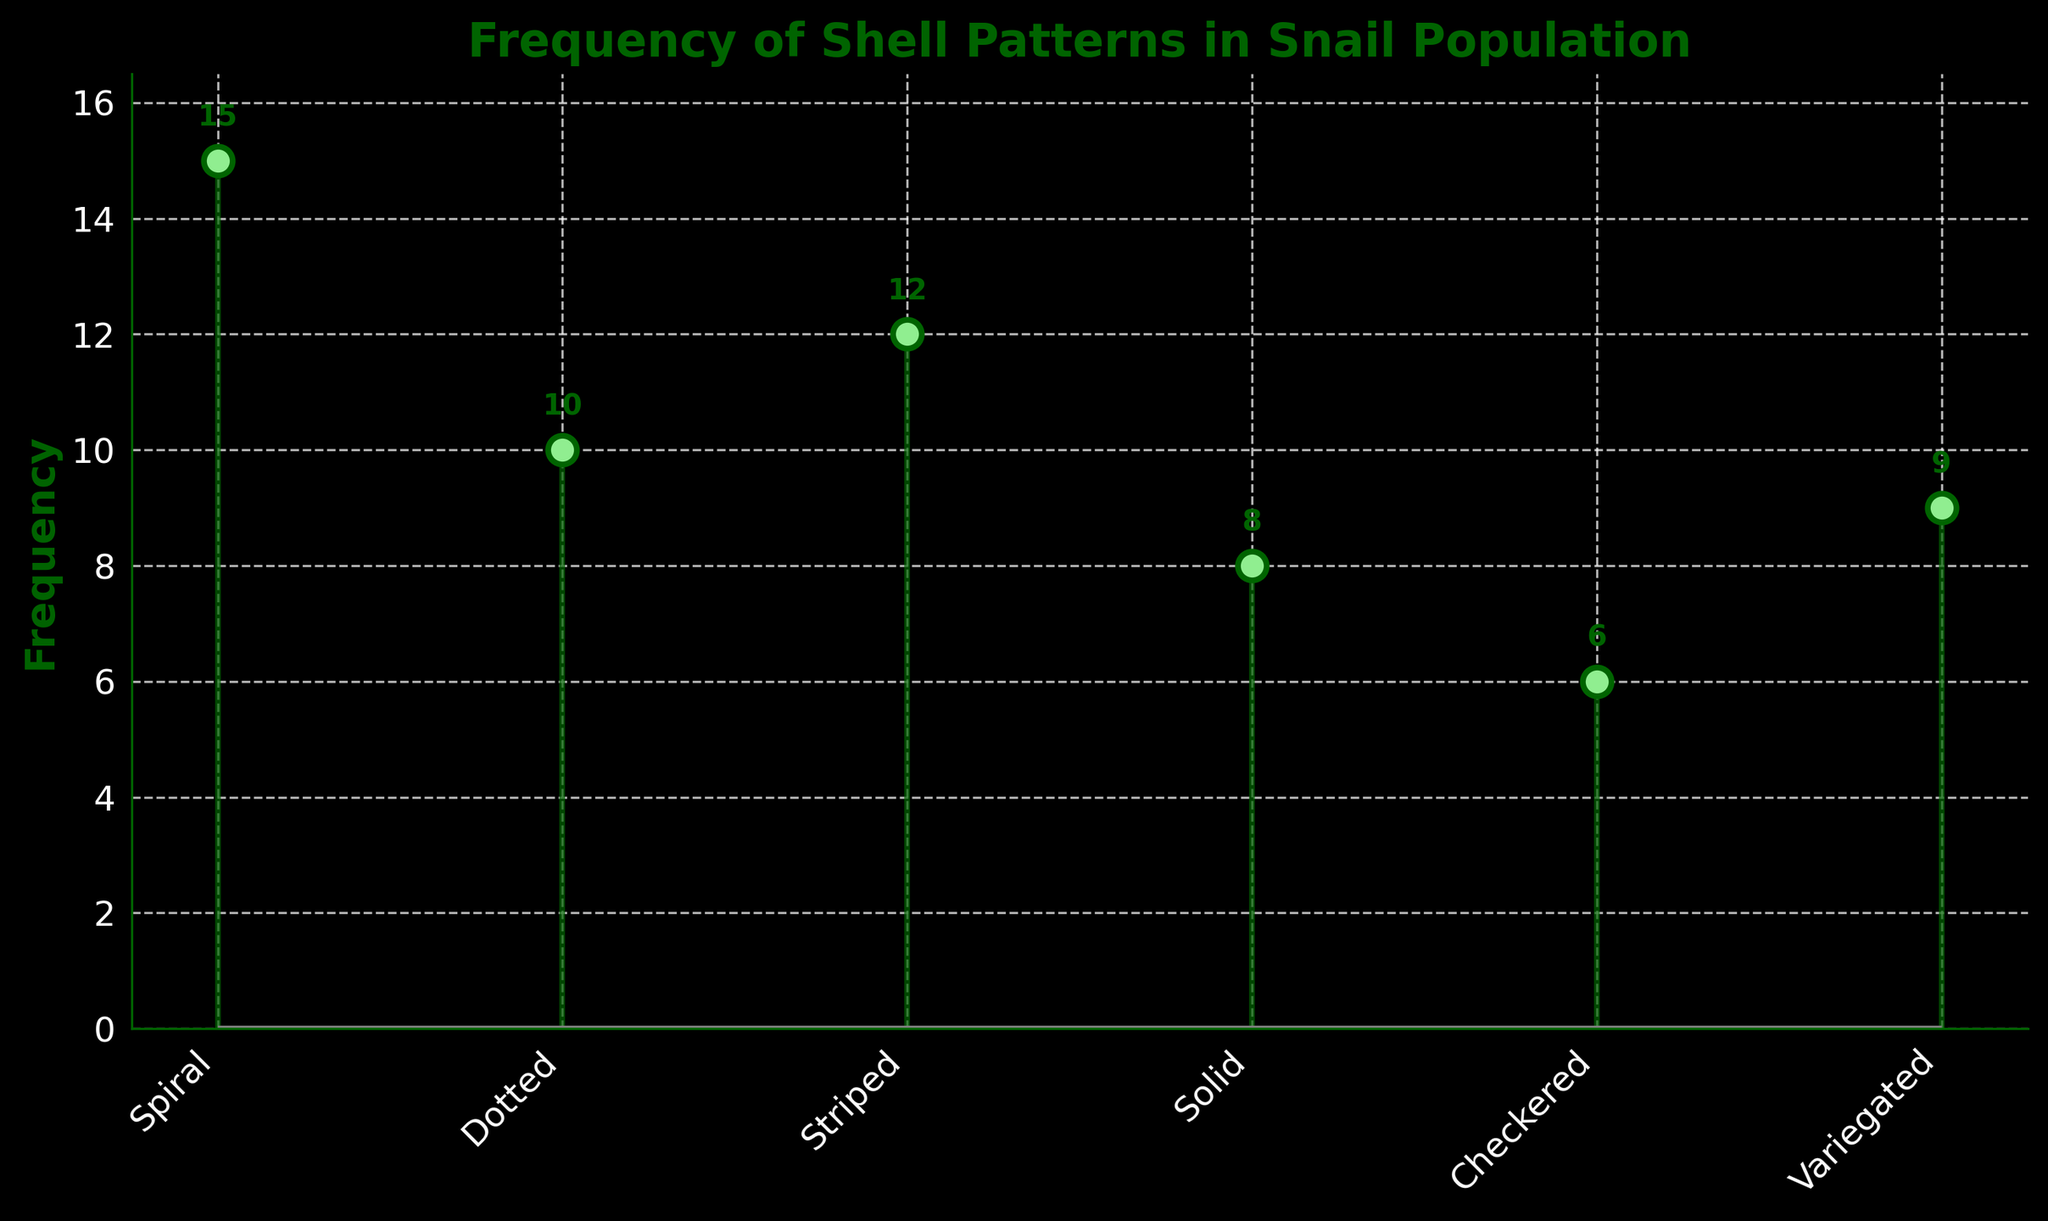What is the title of the plot? The title is displayed at the top of the plot. It indicates the subject of the plot.
Answer: Frequency of Shell Patterns in Snail Population What is the frequency of striped shell patterns? Look at the stem associated with "Striped" shell patterns and read the value at the top.
Answer: 12 How many patterns have a frequency greater than 10? Identify the frequencies listed in the plot and count those that are greater than 10. Both "Spiral" and "Striped" shell patterns meet this criterion.
Answer: 2 Which shell pattern has the lowest frequency? Identify the stem with the lowest value. The "Checkered" shell pattern has the lowest frequency.
Answer: Checkered What is the total frequency of all shell patterns combined? Sum all the frequencies from the plot: 15 (Spiral) + 10 (Dotted) + 12 (Striped) + 8 (Solid) + 6 (Checkered) + 9 (Variegated).
Answer: 60 What is the difference in frequency between the most and least common shell patterns? Subtract the lowest frequency from the highest frequency: 15 (Spiral) - 6 (Checkered).
Answer: 9 Which shell pattern is more common, Dotted or Solid? Compare the frequencies of the "Dotted" and "Solid" patterns. "Dotted" has a frequency of 10, while "Solid" has a frequency of 8.
Answer: Dotted How many shell patterns have a frequency less than 10? Count the number of shell patterns with frequencies below 10. The "Solid", "Checkered", and "Variegated" patterns fall into this category.
Answer: 3 Is the frequency of the "Variegated" shell pattern closer to the frequency of "Dotted" or "Solid"? Compare the frequency of "Variegated" (9) to the frequencies of "Dotted" (10) and "Solid" (8).
Answer: Dotted If the population size doubled, what would be the new frequency for the "Striped" shell pattern? Multiply the current frequency of the "Striped" shell pattern by 2: 12 * 2.
Answer: 24 